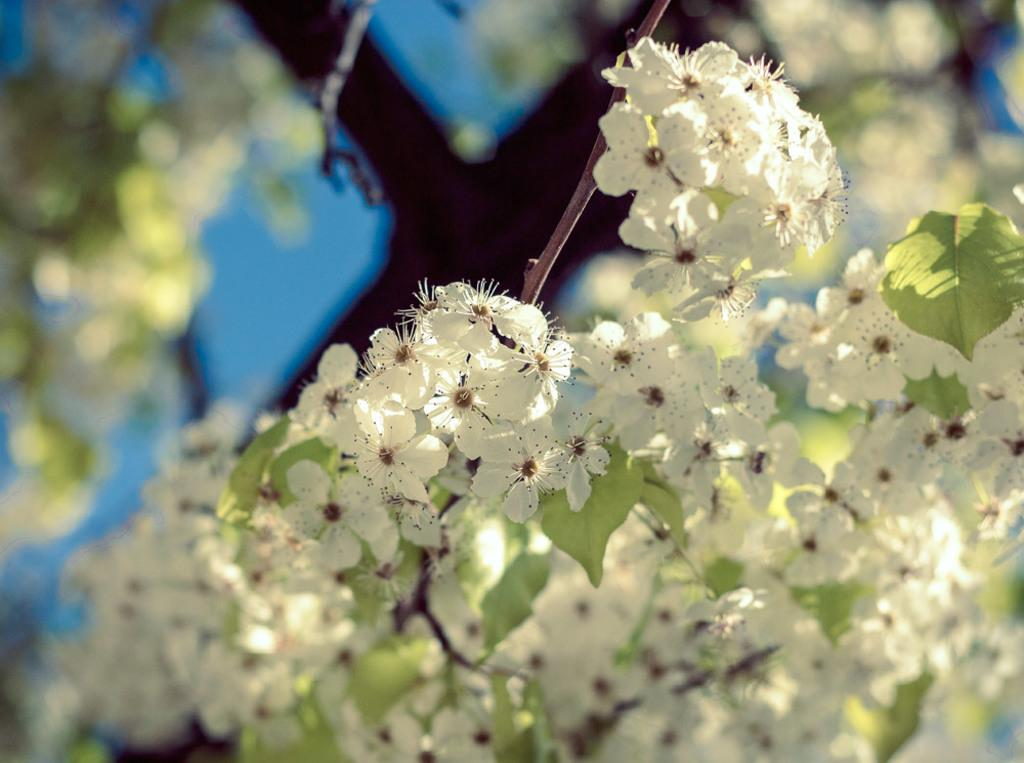What color are the flowers on the plant in the image? The flowers on the plant are white. What color are the leaves on the plant in the image? The leaves on the plant are green. What is visible at the top of the image? The sky is visible at the top of the image. How does the plant express its feelings in the image? Plants do not have feelings, so the plant does not express any feelings in the image. What type of flowers are depicted on the plant in the image? The provided facts do not specify the type of flowers, only their color (white). 